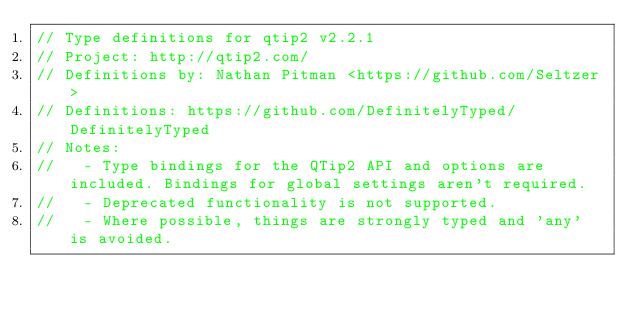Convert code to text. <code><loc_0><loc_0><loc_500><loc_500><_TypeScript_>// Type definitions for qtip2 v2.2.1
// Project: http://qtip2.com/
// Definitions by: Nathan Pitman <https://github.com/Seltzer>
// Definitions: https://github.com/DefinitelyTyped/DefinitelyTyped
// Notes:
//   - Type bindings for the QTip2 API and options are included. Bindings for global settings aren't required.
//   - Deprecated functionality is not supported.
//   - Where possible, things are strongly typed and 'any' is avoided.</code> 